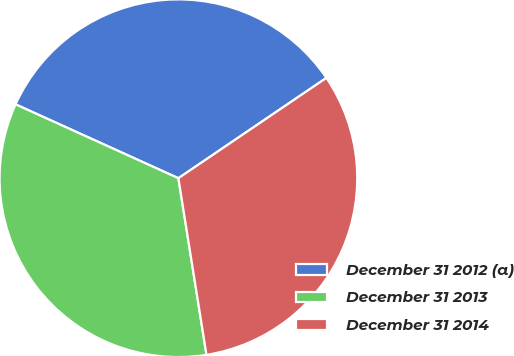Convert chart. <chart><loc_0><loc_0><loc_500><loc_500><pie_chart><fcel>December 31 2012 (a)<fcel>December 31 2013<fcel>December 31 2014<nl><fcel>33.74%<fcel>34.29%<fcel>31.97%<nl></chart> 